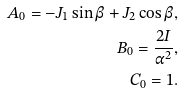<formula> <loc_0><loc_0><loc_500><loc_500>A _ { 0 } = - J _ { 1 } \sin \beta + J _ { 2 } \cos \beta , \\ B _ { 0 } = \frac { 2 I } { \alpha ^ { 2 } } , \\ C _ { 0 } = 1 .</formula> 